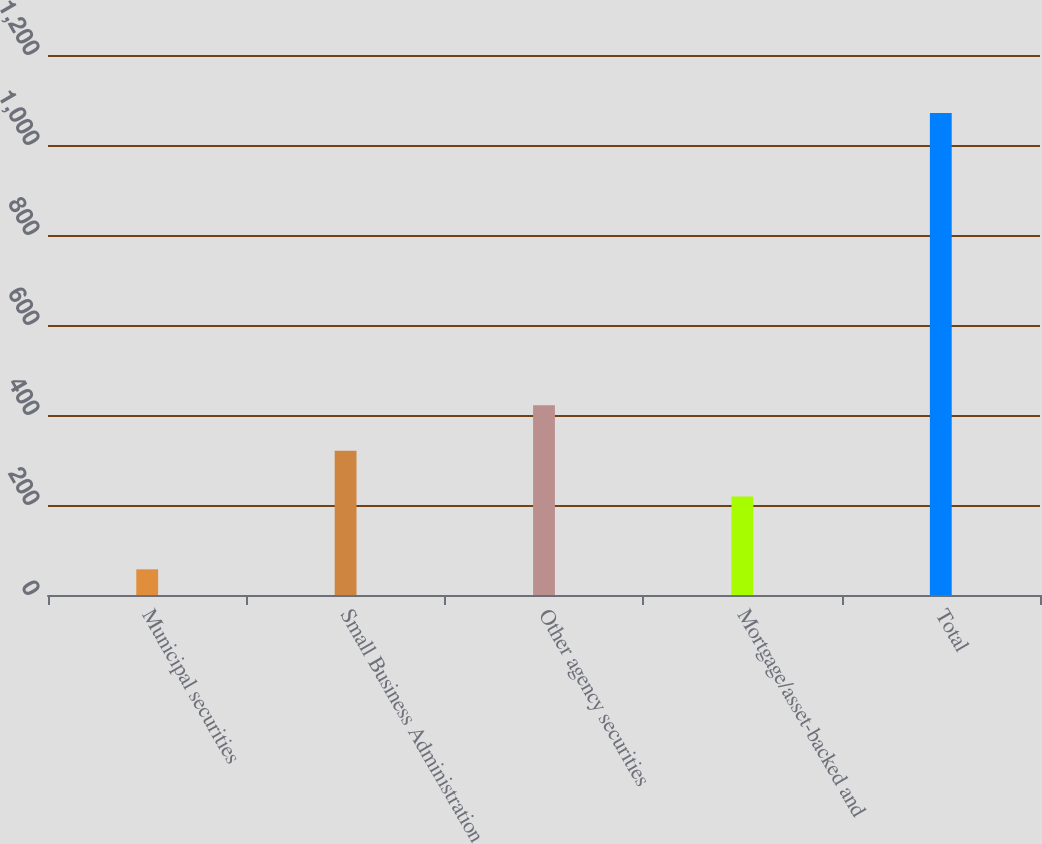Convert chart. <chart><loc_0><loc_0><loc_500><loc_500><bar_chart><fcel>Municipal securities<fcel>Small Business Administration<fcel>Other agency securities<fcel>Mortgage/asset-backed and<fcel>Total<nl><fcel>57<fcel>320.4<fcel>421.8<fcel>219<fcel>1071<nl></chart> 